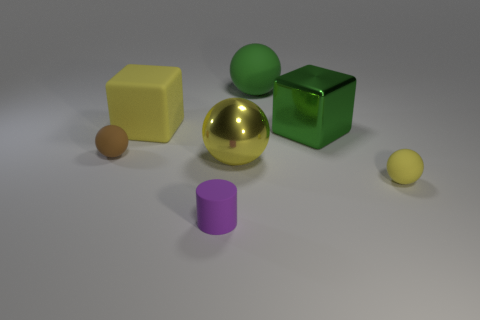What number of matte objects are tiny yellow spheres or gray blocks?
Make the answer very short. 1. Are there any small objects made of the same material as the large green cube?
Provide a succinct answer. No. What number of things are objects that are behind the purple matte cylinder or things that are in front of the large yellow metal object?
Offer a terse response. 7. There is a tiny matte sphere that is on the right side of the tiny cylinder; does it have the same color as the matte cylinder?
Your answer should be compact. No. What number of other things are the same color as the big shiny cube?
Your answer should be very brief. 1. What is the large green cube made of?
Offer a very short reply. Metal. There is a green ball behind the yellow metallic object; does it have the same size as the cylinder?
Offer a terse response. No. Are there any other things that have the same size as the purple cylinder?
Keep it short and to the point. Yes. What is the size of the shiny object that is the same shape as the small brown rubber thing?
Give a very brief answer. Large. Are there an equal number of large matte spheres right of the large matte sphere and tiny yellow matte balls that are in front of the cylinder?
Provide a short and direct response. Yes. 